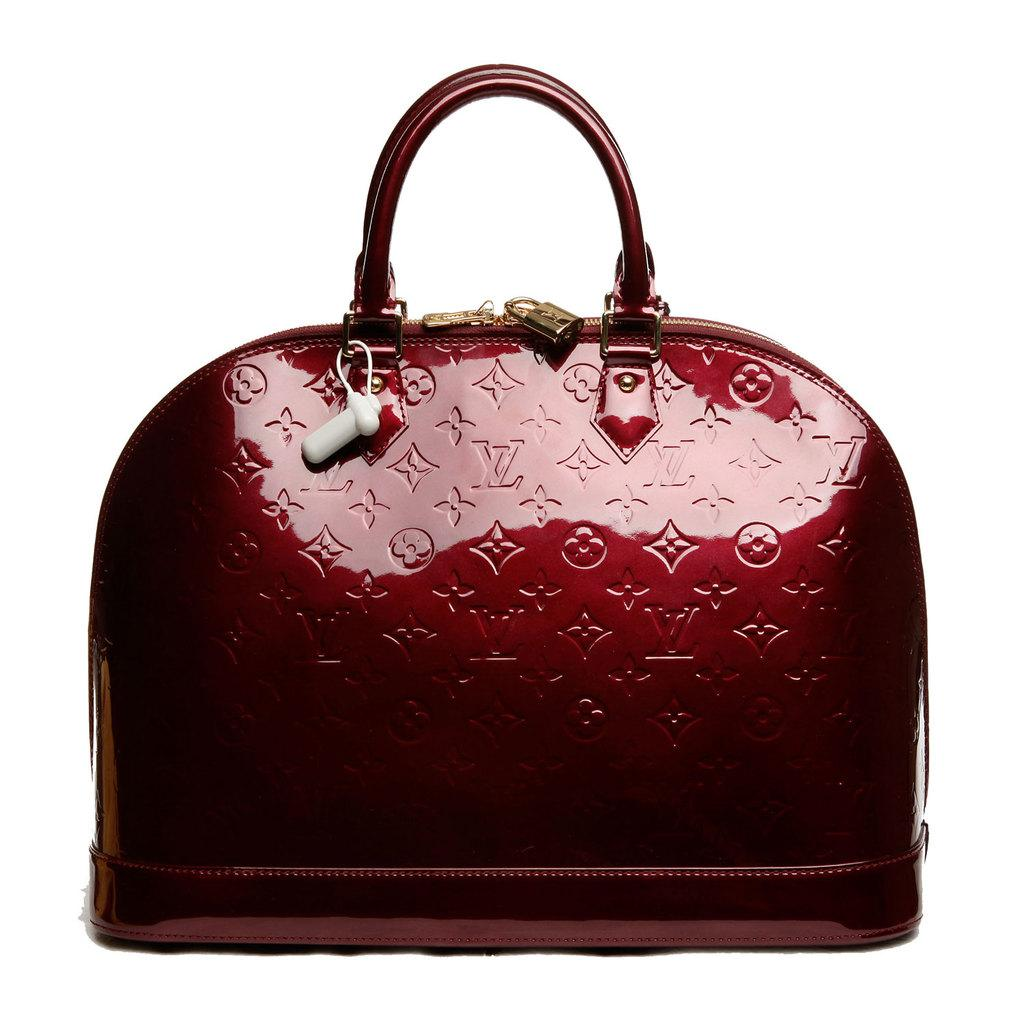What is present in the image related to carrying items? There is a bag in the image. What is the color of the bag? The bag is brown in color. What feature of the bag allows it to be carried easily? The bag has a handle. How can the contents of the bag be secured? The bag has zips. Is there any additional information provided on the bag? There is a tag on the bag. Can you tell me how many cups are inside the bag? There is no information about cups being present in the image, so it cannot be determined if any are inside the bag. 